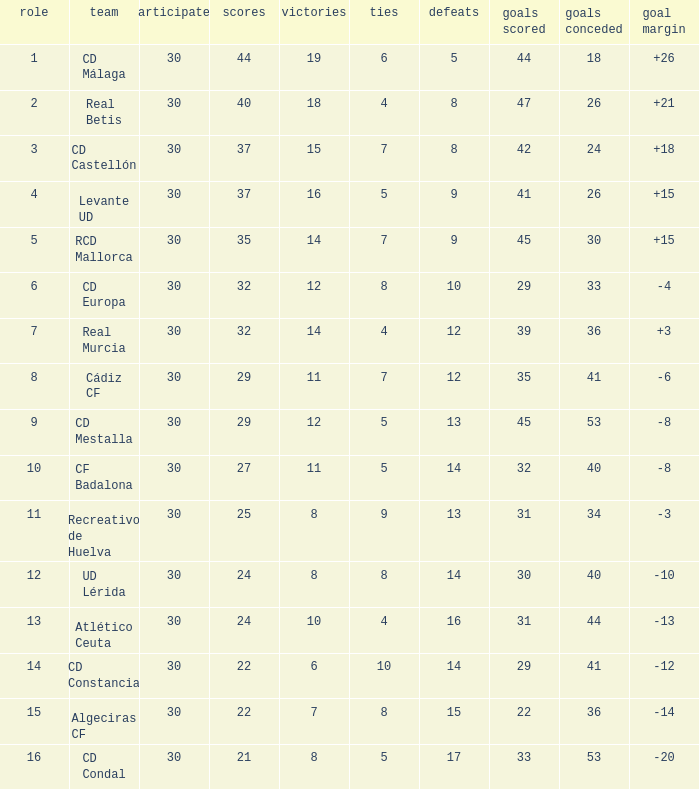What is the number of wins when the goals against is larger than 41, points is 29, and draws are larger than 5? 0.0. 